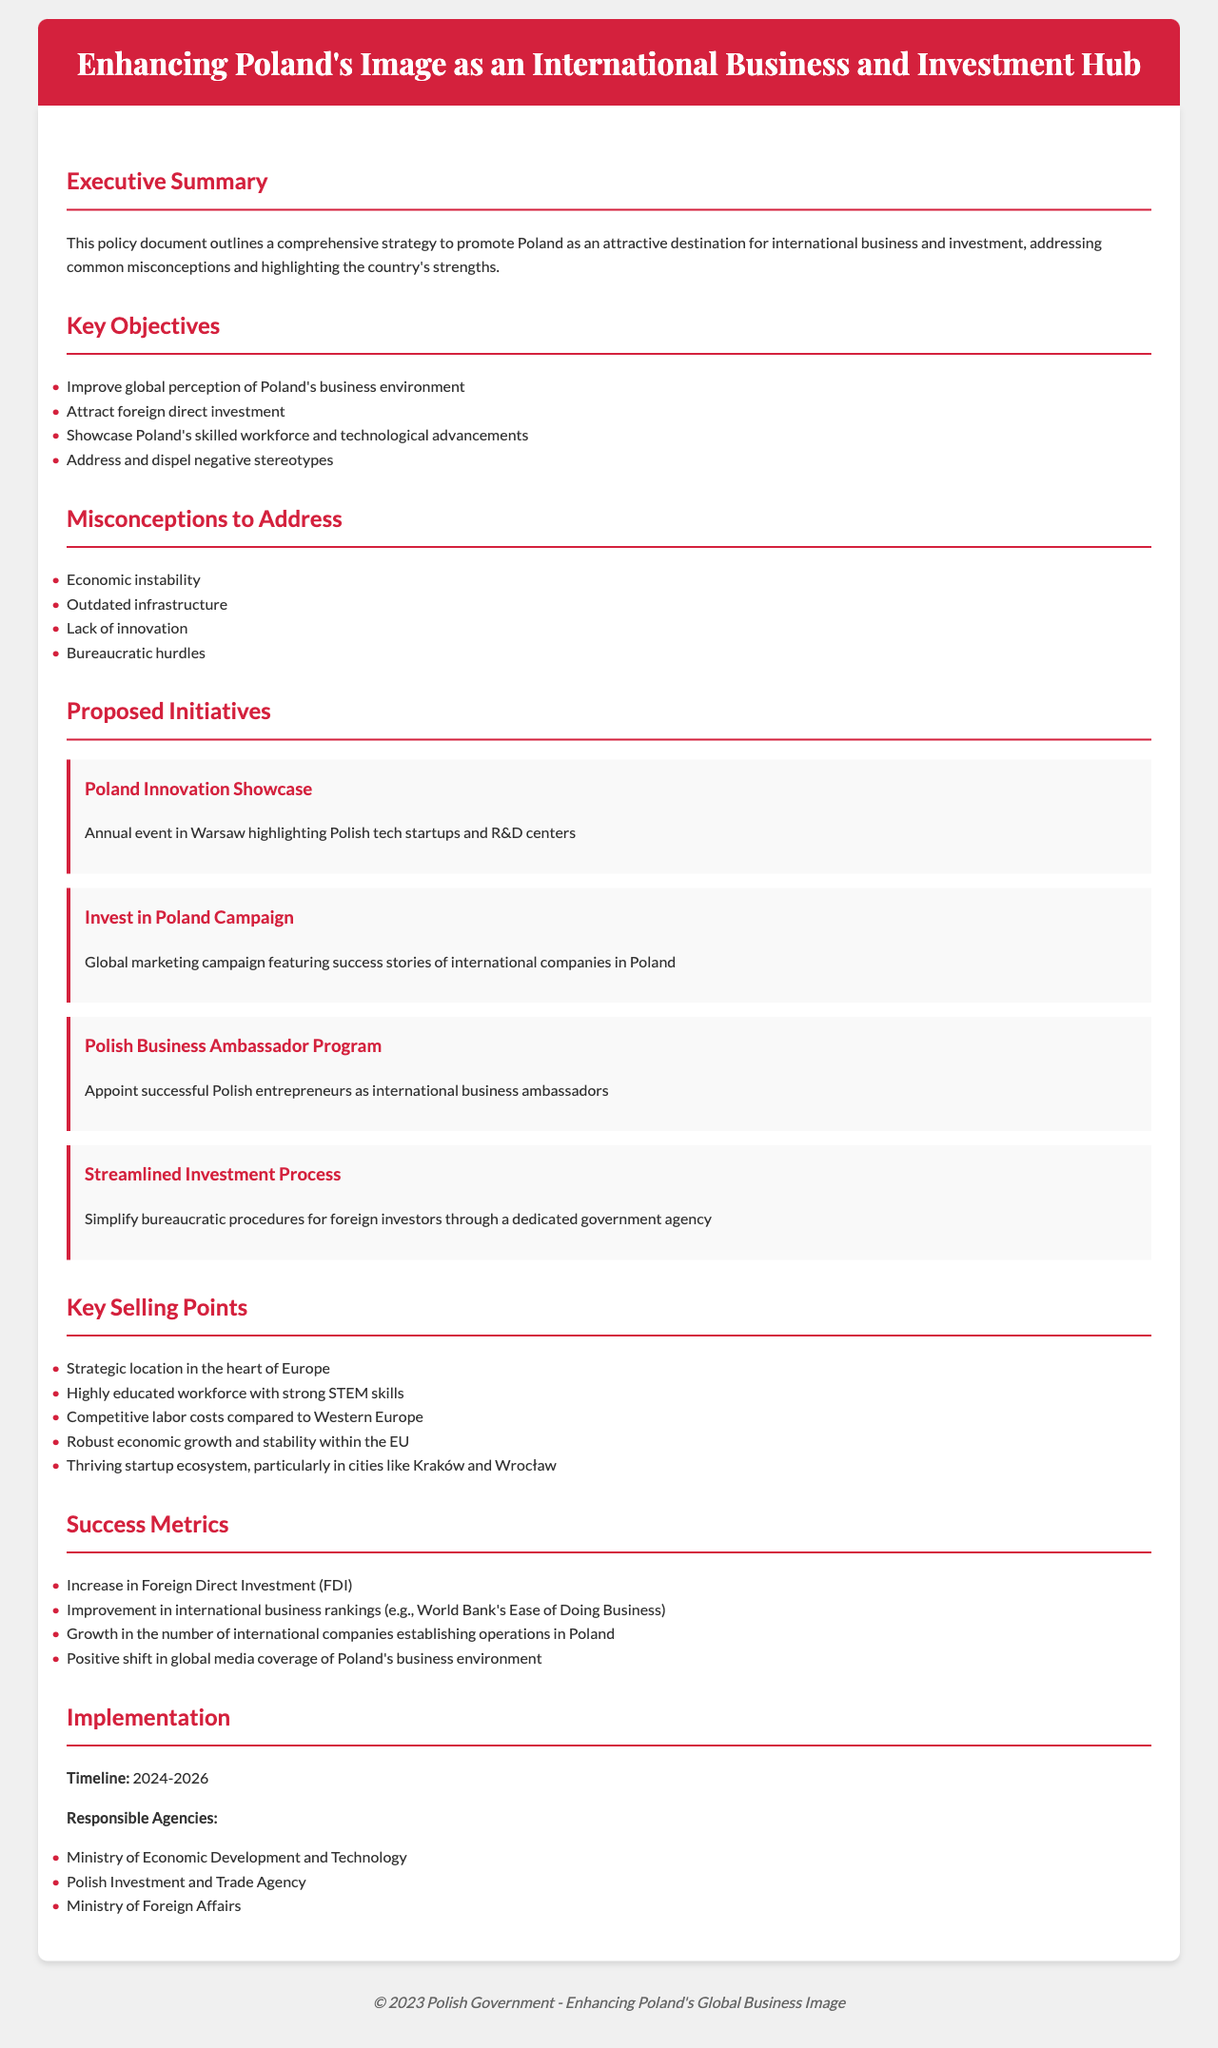What is the title of the document? The title of the document is displayed in the header section, which outlines the focus on enhancing Poland's image as a business hub.
Answer: Enhancing Poland's Image as an International Business and Investment Hub What is the timeline for implementation? The timeline for implementation indicates the years that the proposed initiatives will take place, stated in the implementation section.
Answer: 2024-2026 Which agency is responsible for implementing the initiatives? The document lists multiple responsible agencies for the implementation, specifically mentioned in the implementation section.
Answer: Ministry of Economic Development and Technology What key misconception relates to Poland's infrastructure? One of the misconceptions listed addresses a specific concern related to how infrastructure is perceived in Poland.
Answer: Outdated infrastructure Name a proposed initiative that showcases Polish tech startups. The document provides specific initiatives, including one that focuses on technology and innovation, mentioned in the proposed initiatives section.
Answer: Poland Innovation Showcase What is one key selling point of Poland? The document highlights several selling points, emphasizing advantages that Poland offers for international business, detailed in the key selling points section.
Answer: Strategic location in the heart of Europe How many key objectives are listed in the document? The key objectives outlined in the document are enumerated in their section, which can be counted for a specific number.
Answer: Four What is a metric for success mentioned in the document? The document specifies how success will be measured, including key metrics that are relevant to assessing the initiatives.
Answer: Increase in Foreign Direct Investment (FDI) 